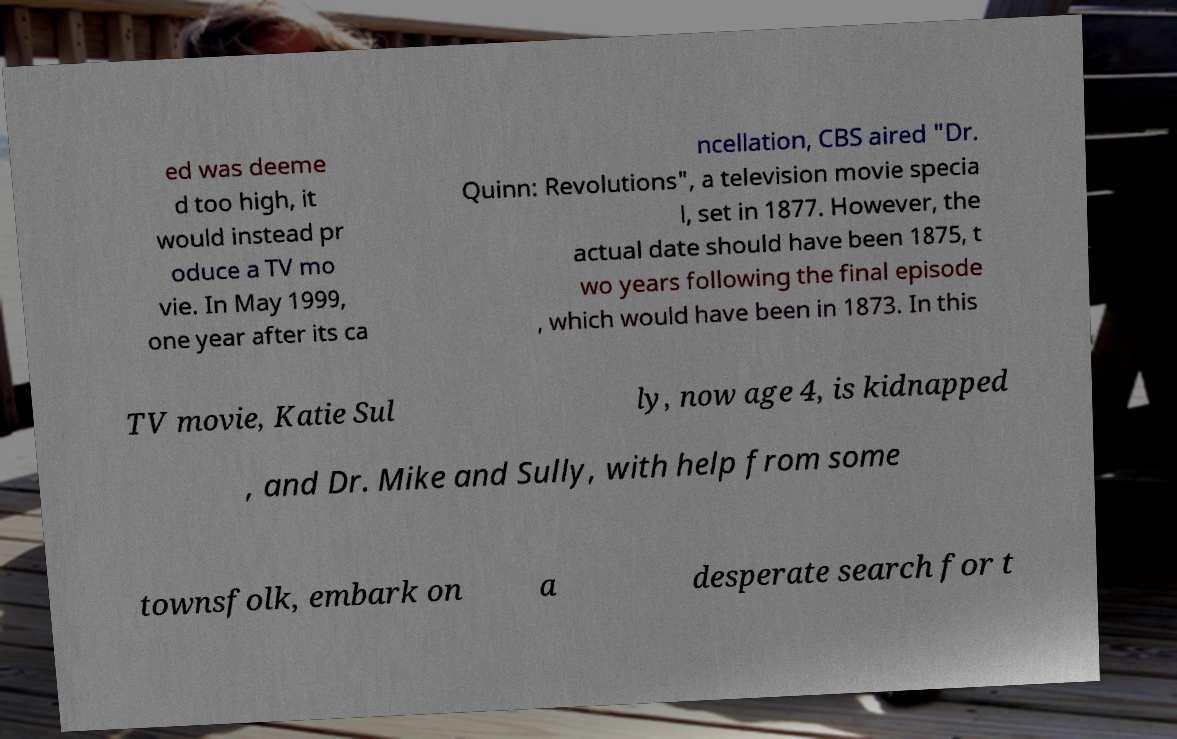For documentation purposes, I need the text within this image transcribed. Could you provide that? ed was deeme d too high, it would instead pr oduce a TV mo vie. In May 1999, one year after its ca ncellation, CBS aired "Dr. Quinn: Revolutions", a television movie specia l, set in 1877. However, the actual date should have been 1875, t wo years following the final episode , which would have been in 1873. In this TV movie, Katie Sul ly, now age 4, is kidnapped , and Dr. Mike and Sully, with help from some townsfolk, embark on a desperate search for t 